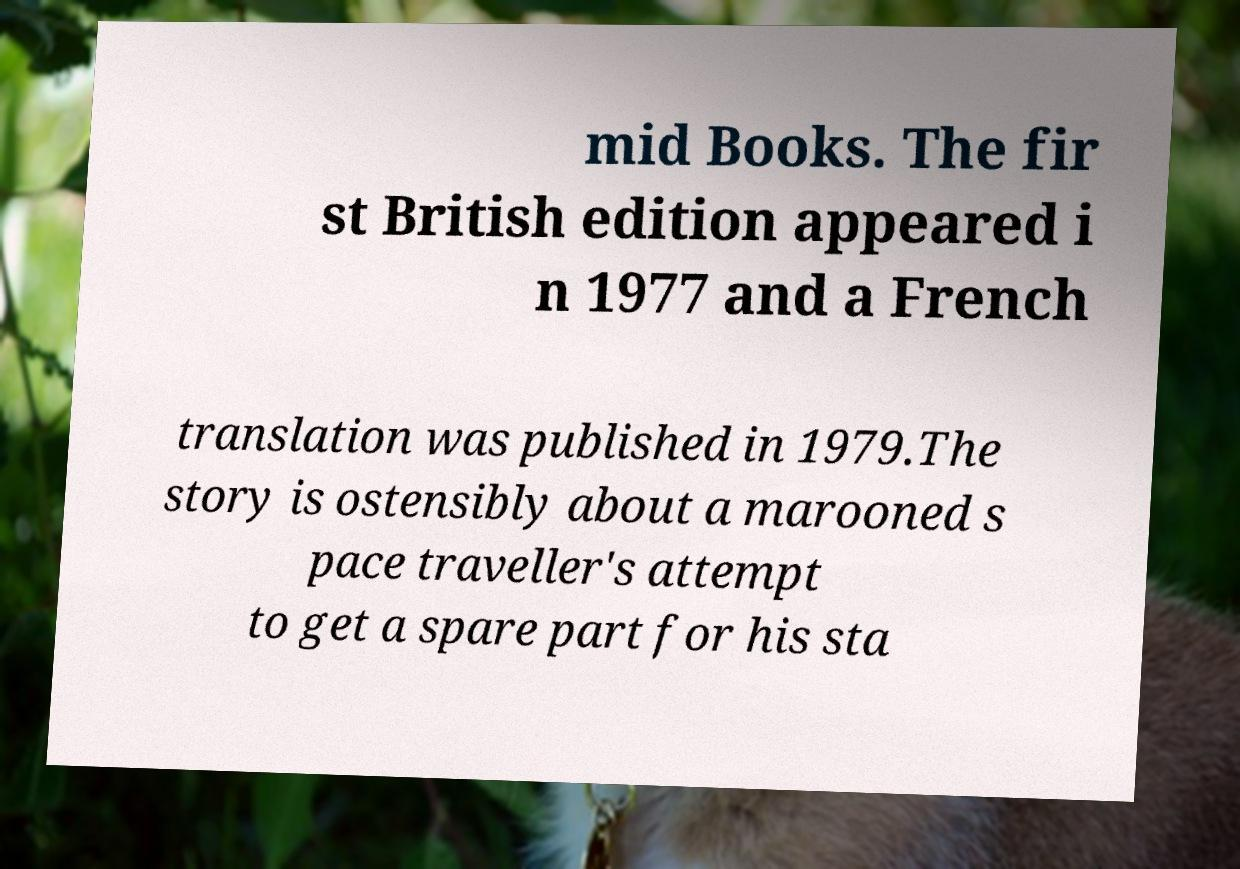Can you read and provide the text displayed in the image?This photo seems to have some interesting text. Can you extract and type it out for me? mid Books. The fir st British edition appeared i n 1977 and a French translation was published in 1979.The story is ostensibly about a marooned s pace traveller's attempt to get a spare part for his sta 